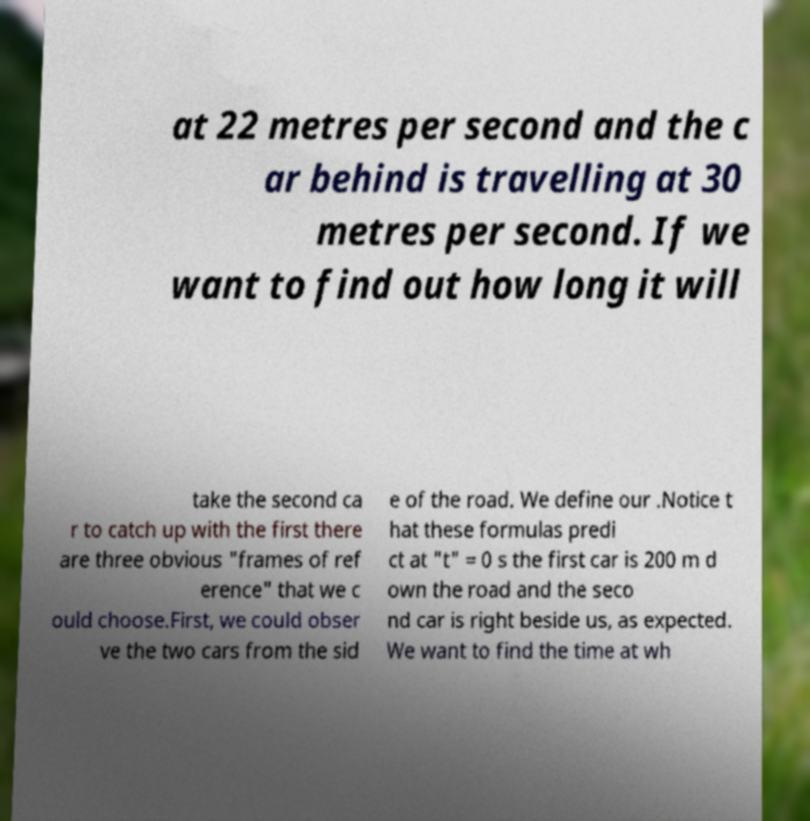Please identify and transcribe the text found in this image. at 22 metres per second and the c ar behind is travelling at 30 metres per second. If we want to find out how long it will take the second ca r to catch up with the first there are three obvious "frames of ref erence" that we c ould choose.First, we could obser ve the two cars from the sid e of the road. We define our .Notice t hat these formulas predi ct at "t" = 0 s the first car is 200 m d own the road and the seco nd car is right beside us, as expected. We want to find the time at wh 